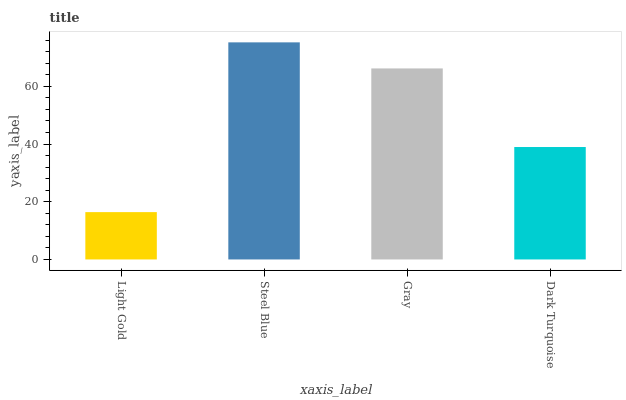Is Gray the minimum?
Answer yes or no. No. Is Gray the maximum?
Answer yes or no. No. Is Steel Blue greater than Gray?
Answer yes or no. Yes. Is Gray less than Steel Blue?
Answer yes or no. Yes. Is Gray greater than Steel Blue?
Answer yes or no. No. Is Steel Blue less than Gray?
Answer yes or no. No. Is Gray the high median?
Answer yes or no. Yes. Is Dark Turquoise the low median?
Answer yes or no. Yes. Is Dark Turquoise the high median?
Answer yes or no. No. Is Light Gold the low median?
Answer yes or no. No. 